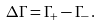Convert formula to latex. <formula><loc_0><loc_0><loc_500><loc_500>\Delta \Gamma = \Gamma _ { + } - \Gamma _ { - } \, .</formula> 